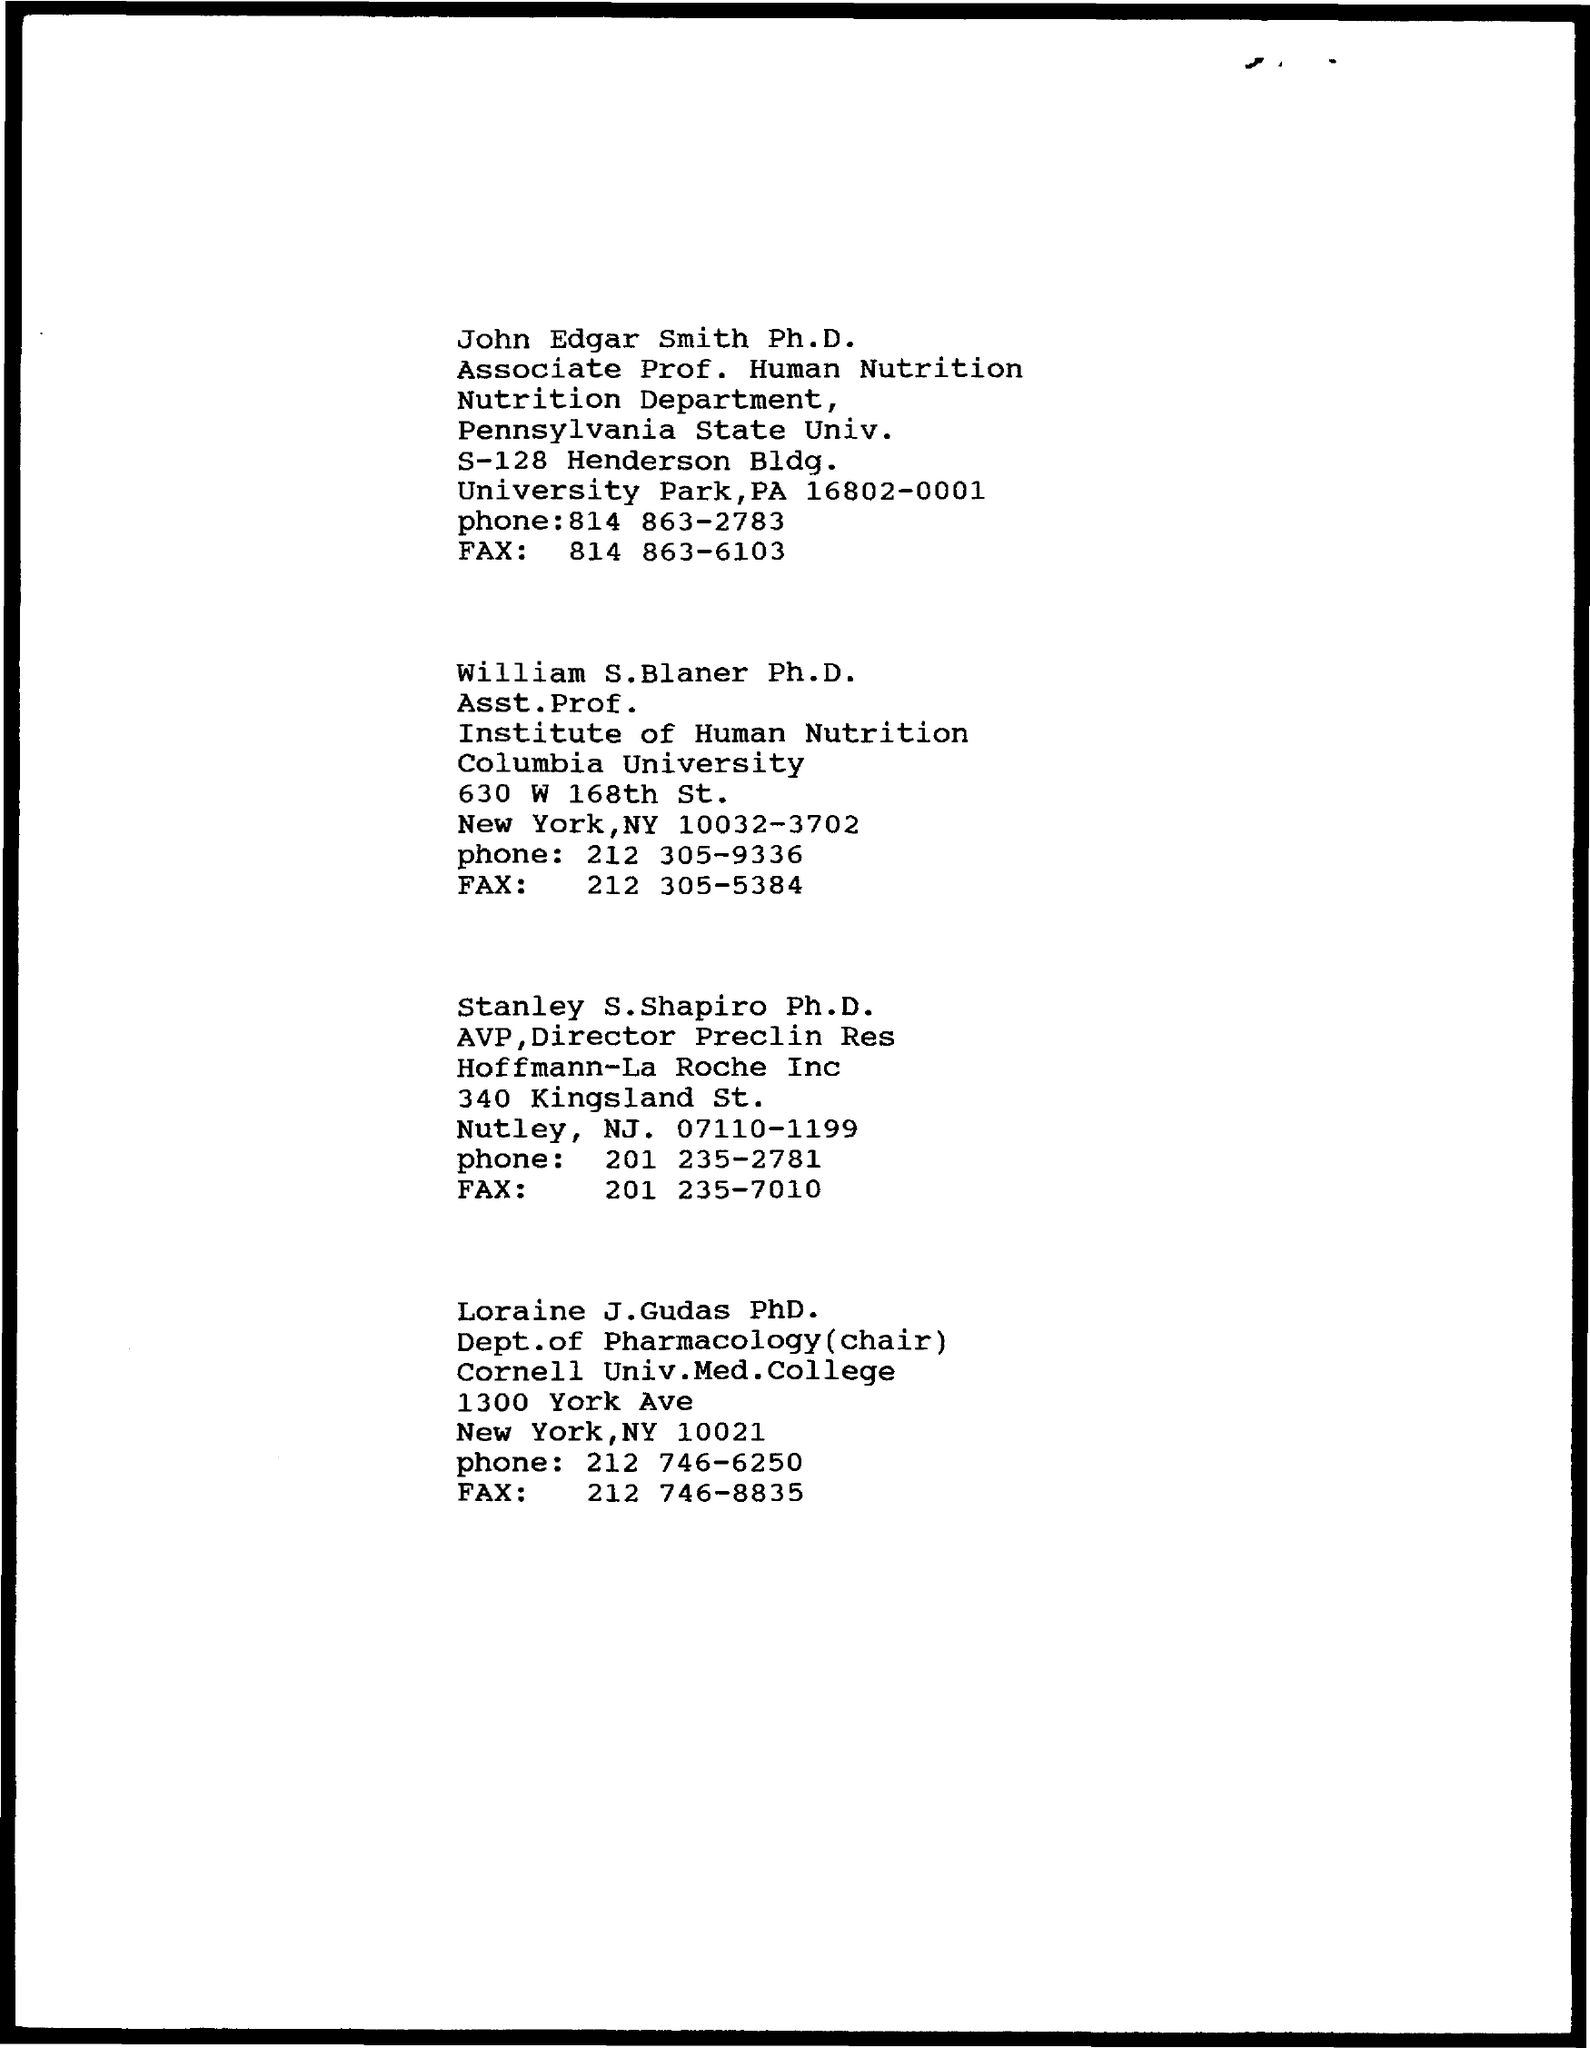Give some essential details in this illustration. William S. Blaner is affiliated with Columbia University. 